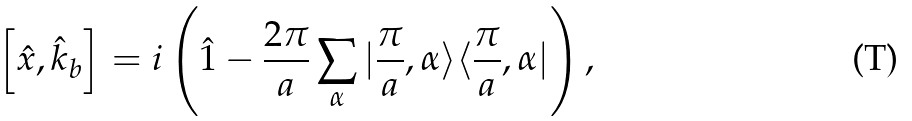<formula> <loc_0><loc_0><loc_500><loc_500>\left [ \hat { x } , \hat { k } _ { b } \right ] = i \left ( \hat { 1 } - \frac { 2 \pi } { a } \sum _ { \alpha } | \frac { \pi } { a } , \alpha \rangle \langle \frac { \pi } { a } , \alpha | \right ) ,</formula> 